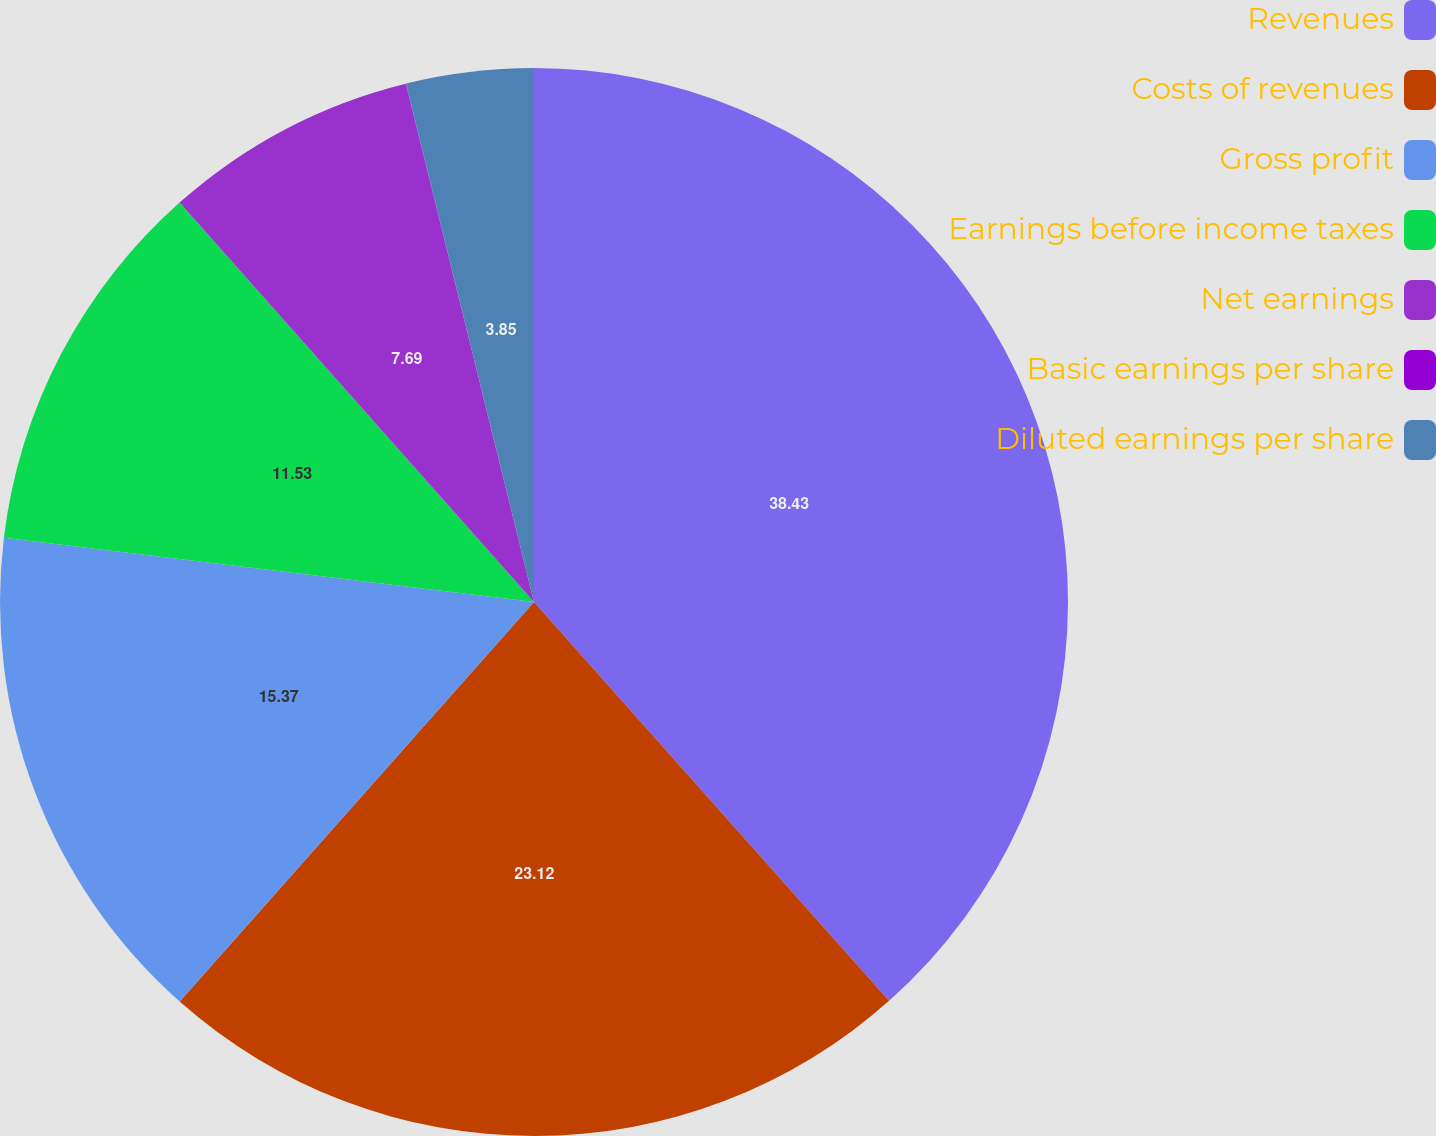Convert chart to OTSL. <chart><loc_0><loc_0><loc_500><loc_500><pie_chart><fcel>Revenues<fcel>Costs of revenues<fcel>Gross profit<fcel>Earnings before income taxes<fcel>Net earnings<fcel>Basic earnings per share<fcel>Diluted earnings per share<nl><fcel>38.42%<fcel>23.12%<fcel>15.37%<fcel>11.53%<fcel>7.69%<fcel>0.01%<fcel>3.85%<nl></chart> 